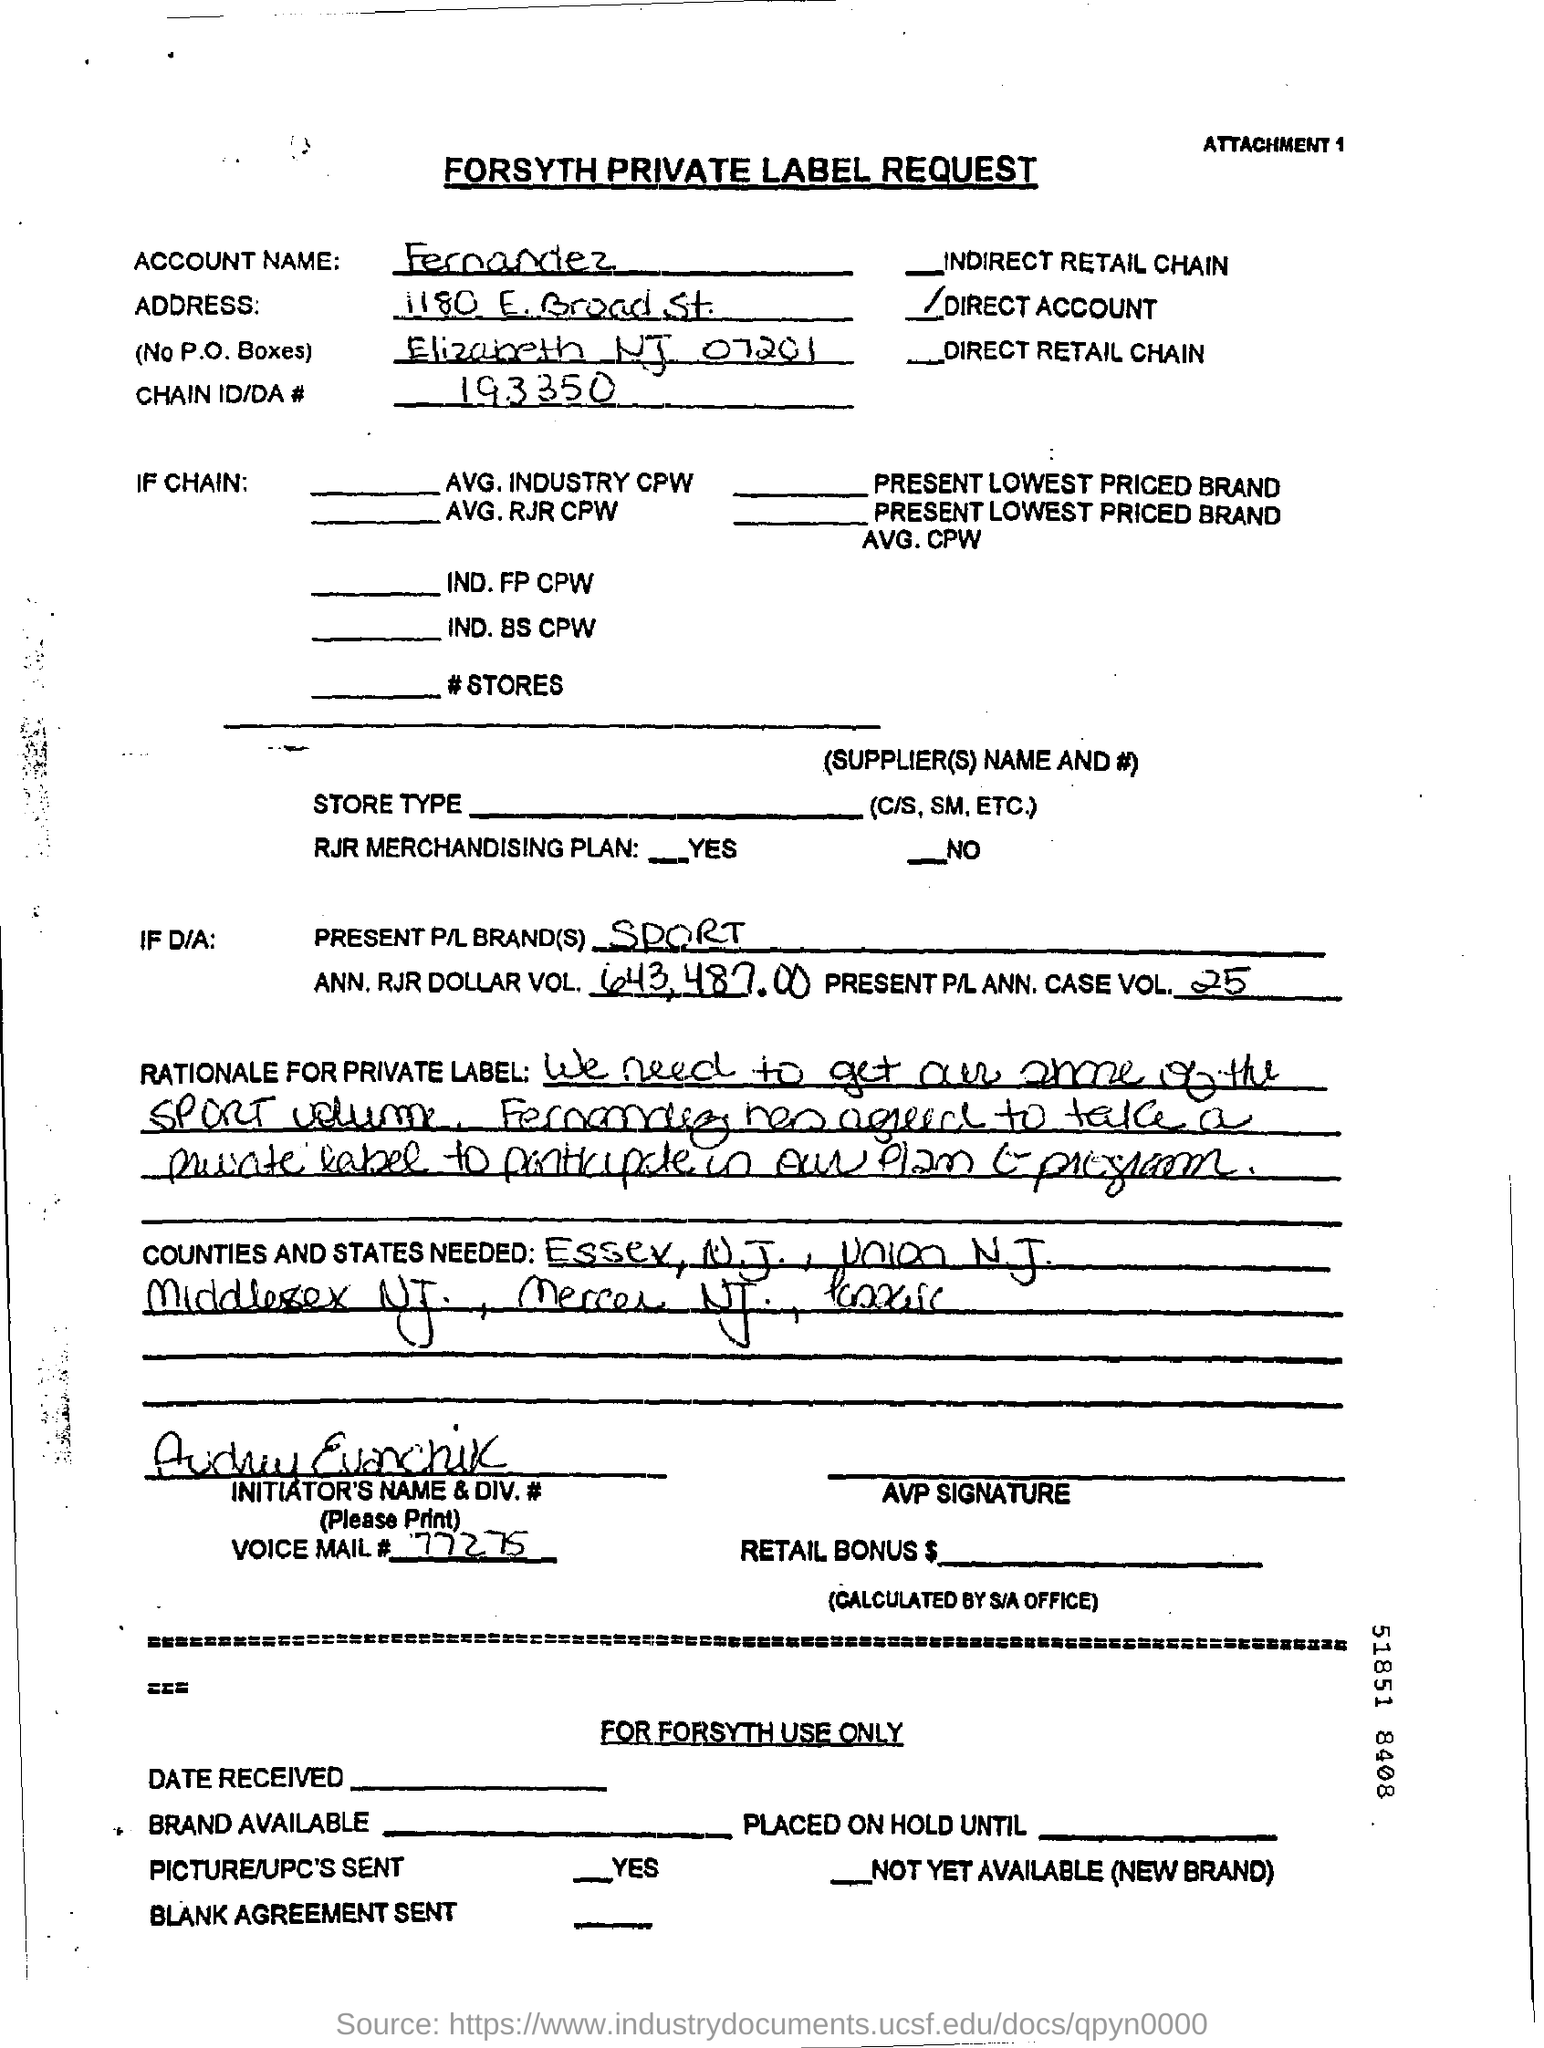What is the Account Name?
Offer a terse response. Fernandez. What is the Chain ID/DA #?
Offer a very short reply. 193350. What is the Present P/L Brand(s)?
Your response must be concise. Sport. What is the ANN. RJR DOLLAR VOL. ?
Your answer should be compact. 643,487.00. What is the Present P/L ANN Case VOL. ??
Your answer should be compact. 25. 